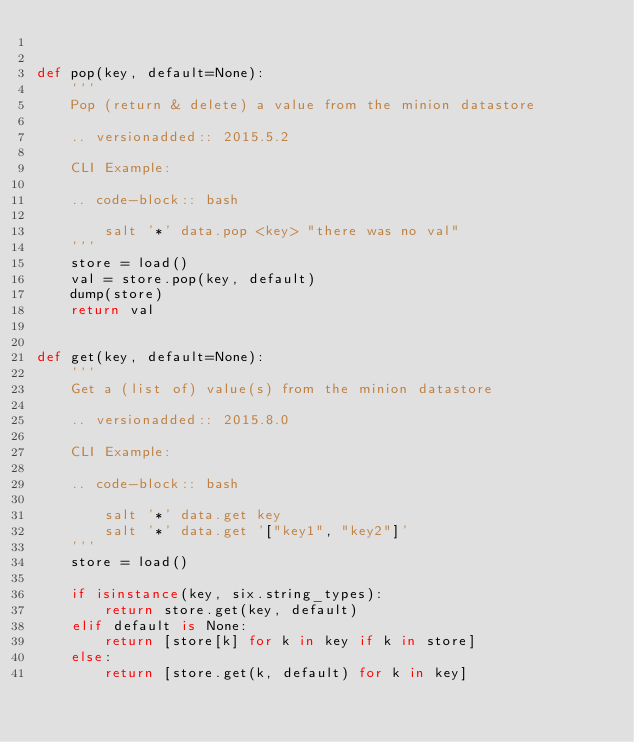<code> <loc_0><loc_0><loc_500><loc_500><_Python_>

def pop(key, default=None):
    '''
    Pop (return & delete) a value from the minion datastore

    .. versionadded:: 2015.5.2

    CLI Example:

    .. code-block:: bash

        salt '*' data.pop <key> "there was no val"
    '''
    store = load()
    val = store.pop(key, default)
    dump(store)
    return val


def get(key, default=None):
    '''
    Get a (list of) value(s) from the minion datastore

    .. versionadded:: 2015.8.0

    CLI Example:

    .. code-block:: bash

        salt '*' data.get key
        salt '*' data.get '["key1", "key2"]'
    '''
    store = load()

    if isinstance(key, six.string_types):
        return store.get(key, default)
    elif default is None:
        return [store[k] for k in key if k in store]
    else:
        return [store.get(k, default) for k in key]

</code> 